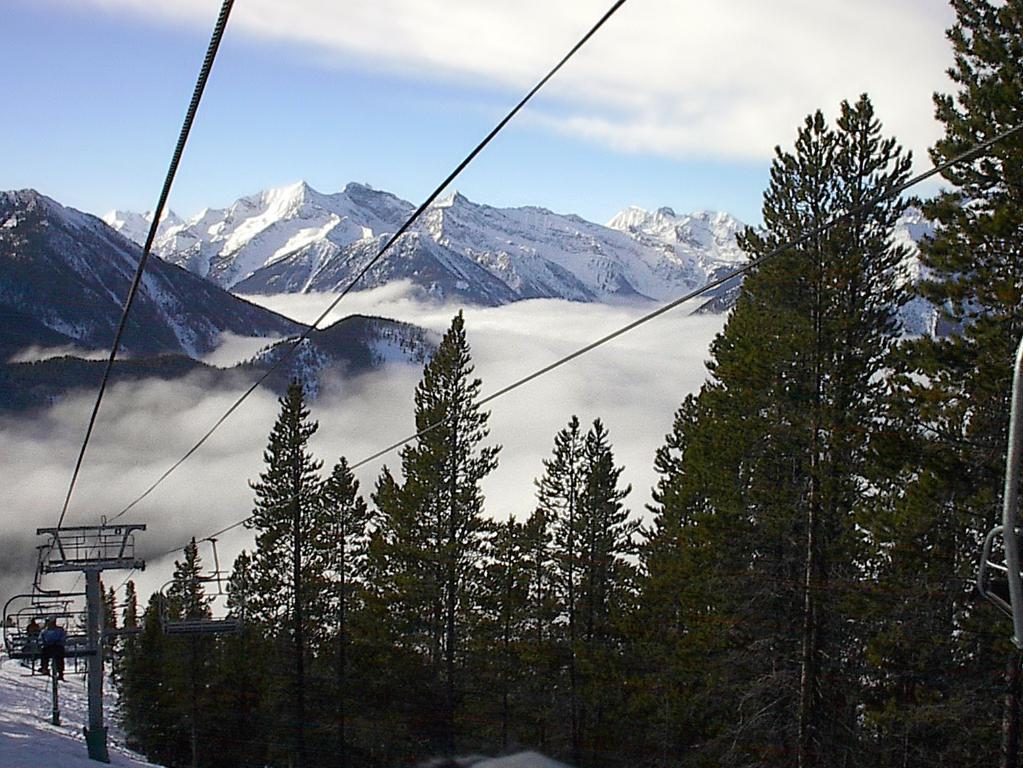Could you give a brief overview of what you see in this image? This picture is clicked outside. In the foreground we can see the trees. On the left we can see the cable cars and the persons and we can see the snow. In the background we can see the sky, hills, smoke and the snow. 